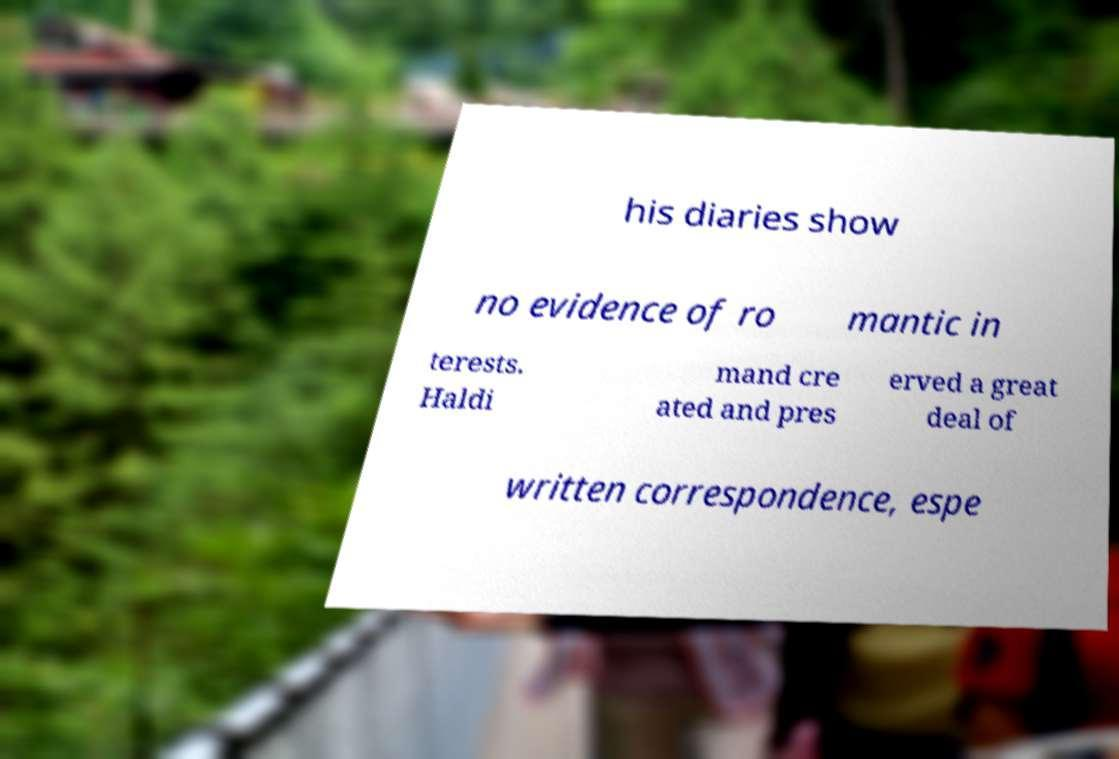Could you extract and type out the text from this image? his diaries show no evidence of ro mantic in terests. Haldi mand cre ated and pres erved a great deal of written correspondence, espe 